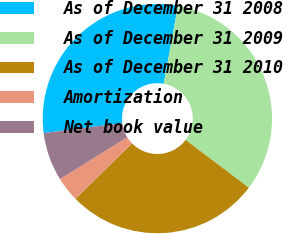<chart> <loc_0><loc_0><loc_500><loc_500><pie_chart><fcel>As of December 31 2008<fcel>As of December 31 2009<fcel>As of December 31 2010<fcel>Amortization<fcel>Net book value<nl><fcel>29.9%<fcel>32.42%<fcel>27.37%<fcel>3.49%<fcel>6.82%<nl></chart> 